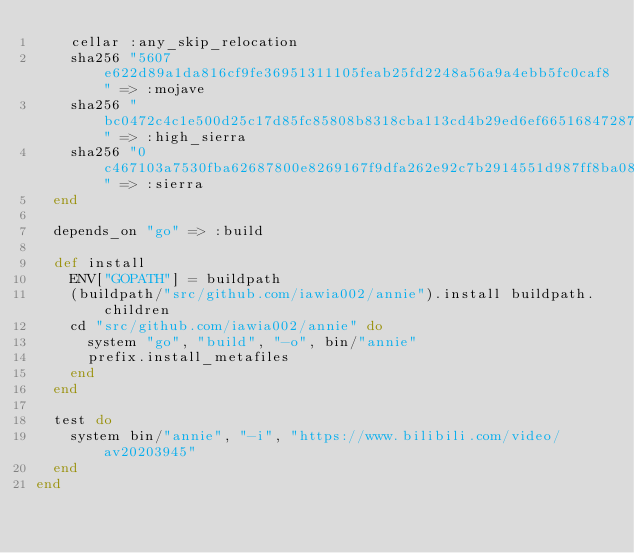<code> <loc_0><loc_0><loc_500><loc_500><_Ruby_>    cellar :any_skip_relocation
    sha256 "5607e622d89a1da816cf9fe36951311105feab25fd2248a56a9a4ebb5fc0caf8" => :mojave
    sha256 "bc0472c4c1e500d25c17d85fc85808b8318cba113cd4b29ed6ef66516847287b" => :high_sierra
    sha256 "0c467103a7530fba62687800e8269167f9dfa262e92c7b2914551d987ff8ba08" => :sierra
  end

  depends_on "go" => :build

  def install
    ENV["GOPATH"] = buildpath
    (buildpath/"src/github.com/iawia002/annie").install buildpath.children
    cd "src/github.com/iawia002/annie" do
      system "go", "build", "-o", bin/"annie"
      prefix.install_metafiles
    end
  end

  test do
    system bin/"annie", "-i", "https://www.bilibili.com/video/av20203945"
  end
end
</code> 